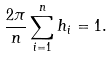<formula> <loc_0><loc_0><loc_500><loc_500>\frac { 2 \pi } { n } \sum _ { i = 1 } ^ { n } h _ { i } = 1 .</formula> 